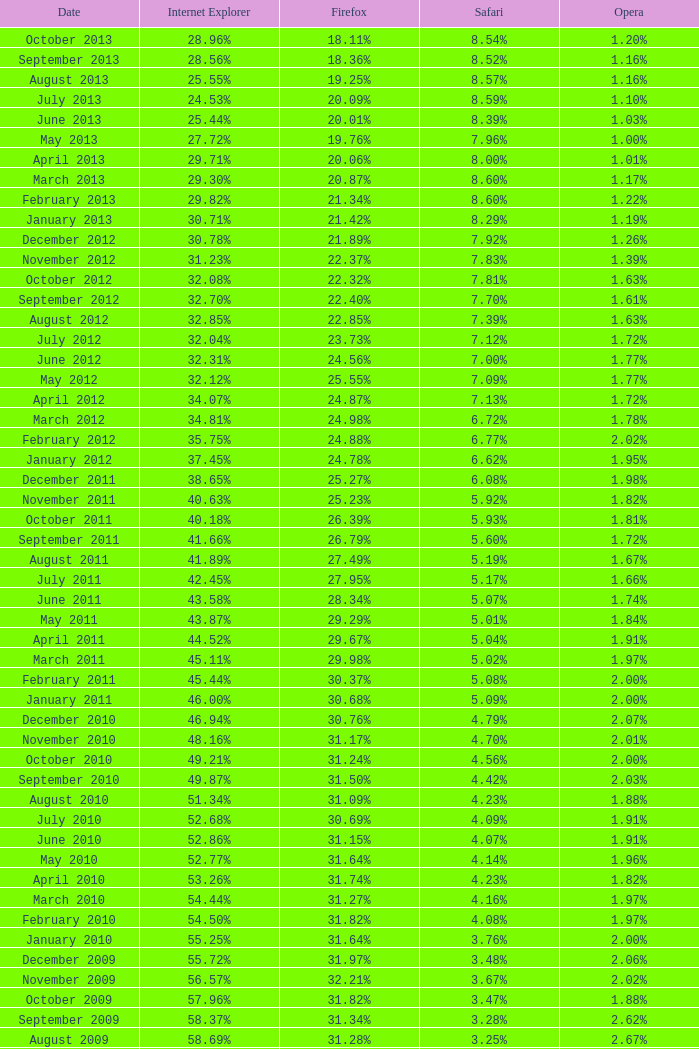Could you parse the entire table as a dict? {'header': ['Date', 'Internet Explorer', 'Firefox', 'Safari', 'Opera'], 'rows': [['October 2013', '28.96%', '18.11%', '8.54%', '1.20%'], ['September 2013', '28.56%', '18.36%', '8.52%', '1.16%'], ['August 2013', '25.55%', '19.25%', '8.57%', '1.16%'], ['July 2013', '24.53%', '20.09%', '8.59%', '1.10%'], ['June 2013', '25.44%', '20.01%', '8.39%', '1.03%'], ['May 2013', '27.72%', '19.76%', '7.96%', '1.00%'], ['April 2013', '29.71%', '20.06%', '8.00%', '1.01%'], ['March 2013', '29.30%', '20.87%', '8.60%', '1.17%'], ['February 2013', '29.82%', '21.34%', '8.60%', '1.22%'], ['January 2013', '30.71%', '21.42%', '8.29%', '1.19%'], ['December 2012', '30.78%', '21.89%', '7.92%', '1.26%'], ['November 2012', '31.23%', '22.37%', '7.83%', '1.39%'], ['October 2012', '32.08%', '22.32%', '7.81%', '1.63%'], ['September 2012', '32.70%', '22.40%', '7.70%', '1.61%'], ['August 2012', '32.85%', '22.85%', '7.39%', '1.63%'], ['July 2012', '32.04%', '23.73%', '7.12%', '1.72%'], ['June 2012', '32.31%', '24.56%', '7.00%', '1.77%'], ['May 2012', '32.12%', '25.55%', '7.09%', '1.77%'], ['April 2012', '34.07%', '24.87%', '7.13%', '1.72%'], ['March 2012', '34.81%', '24.98%', '6.72%', '1.78%'], ['February 2012', '35.75%', '24.88%', '6.77%', '2.02%'], ['January 2012', '37.45%', '24.78%', '6.62%', '1.95%'], ['December 2011', '38.65%', '25.27%', '6.08%', '1.98%'], ['November 2011', '40.63%', '25.23%', '5.92%', '1.82%'], ['October 2011', '40.18%', '26.39%', '5.93%', '1.81%'], ['September 2011', '41.66%', '26.79%', '5.60%', '1.72%'], ['August 2011', '41.89%', '27.49%', '5.19%', '1.67%'], ['July 2011', '42.45%', '27.95%', '5.17%', '1.66%'], ['June 2011', '43.58%', '28.34%', '5.07%', '1.74%'], ['May 2011', '43.87%', '29.29%', '5.01%', '1.84%'], ['April 2011', '44.52%', '29.67%', '5.04%', '1.91%'], ['March 2011', '45.11%', '29.98%', '5.02%', '1.97%'], ['February 2011', '45.44%', '30.37%', '5.08%', '2.00%'], ['January 2011', '46.00%', '30.68%', '5.09%', '2.00%'], ['December 2010', '46.94%', '30.76%', '4.79%', '2.07%'], ['November 2010', '48.16%', '31.17%', '4.70%', '2.01%'], ['October 2010', '49.21%', '31.24%', '4.56%', '2.00%'], ['September 2010', '49.87%', '31.50%', '4.42%', '2.03%'], ['August 2010', '51.34%', '31.09%', '4.23%', '1.88%'], ['July 2010', '52.68%', '30.69%', '4.09%', '1.91%'], ['June 2010', '52.86%', '31.15%', '4.07%', '1.91%'], ['May 2010', '52.77%', '31.64%', '4.14%', '1.96%'], ['April 2010', '53.26%', '31.74%', '4.23%', '1.82%'], ['March 2010', '54.44%', '31.27%', '4.16%', '1.97%'], ['February 2010', '54.50%', '31.82%', '4.08%', '1.97%'], ['January 2010', '55.25%', '31.64%', '3.76%', '2.00%'], ['December 2009', '55.72%', '31.97%', '3.48%', '2.06%'], ['November 2009', '56.57%', '32.21%', '3.67%', '2.02%'], ['October 2009', '57.96%', '31.82%', '3.47%', '1.88%'], ['September 2009', '58.37%', '31.34%', '3.28%', '2.62%'], ['August 2009', '58.69%', '31.28%', '3.25%', '2.67%'], ['July 2009', '60.11%', '30.50%', '3.02%', '2.64%'], ['June 2009', '59.49%', '30.26%', '2.91%', '3.46%'], ['May 2009', '62.09%', '28.75%', '2.65%', '3.23%'], ['April 2009', '61.88%', '29.67%', '2.75%', '2.96%'], ['March 2009', '62.52%', '29.40%', '2.73%', '2.94%'], ['February 2009', '64.43%', '27.85%', '2.59%', '2.95%'], ['January 2009', '65.41%', '27.03%', '2.57%', '2.92%'], ['December 2008', '67.84%', '25.23%', '2.41%', '2.83%'], ['November 2008', '68.14%', '25.27%', '2.49%', '3.01%'], ['October 2008', '67.68%', '25.54%', '2.91%', '2.69%'], ['September2008', '67.16%', '25.77%', '3.00%', '2.86%'], ['August 2008', '68.91%', '26.08%', '2.99%', '1.83%'], ['July 2008', '68.57%', '26.14%', '3.30%', '1.78%']]} What percentage of browsers were using Safari during the period in which 31.27% were using Firefox? 4.16%. 